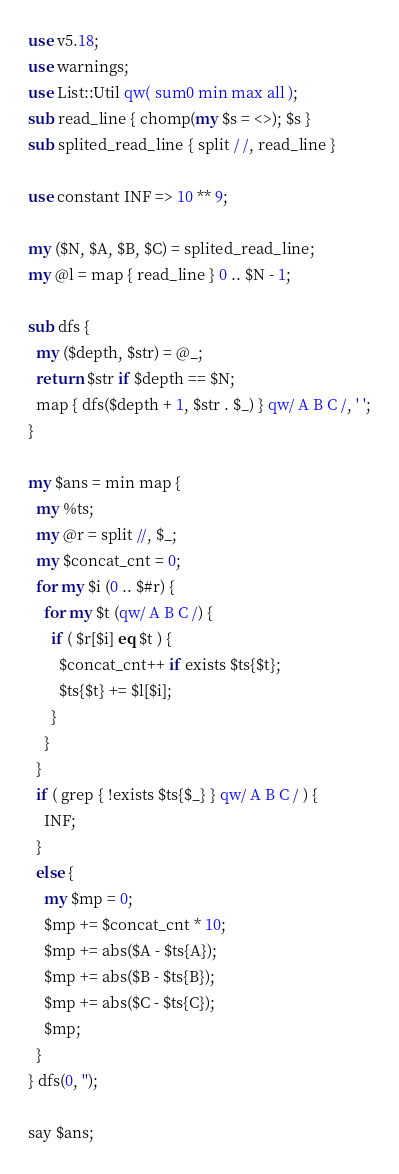Convert code to text. <code><loc_0><loc_0><loc_500><loc_500><_Perl_>use v5.18;
use warnings;
use List::Util qw( sum0 min max all );
sub read_line { chomp(my $s = <>); $s }
sub splited_read_line { split / /, read_line }

use constant INF => 10 ** 9;

my ($N, $A, $B, $C) = splited_read_line;
my @l = map { read_line } 0 .. $N - 1;

sub dfs {
  my ($depth, $str) = @_;
  return $str if $depth == $N;
  map { dfs($depth + 1, $str . $_) } qw/ A B C /, ' ';
}

my $ans = min map {
  my %ts;
  my @r = split //, $_;
  my $concat_cnt = 0;
  for my $i (0 .. $#r) {
    for my $t (qw/ A B C /) {
      if ( $r[$i] eq $t ) {
        $concat_cnt++ if exists $ts{$t};
        $ts{$t} += $l[$i];
      }
    }
  }
  if ( grep { !exists $ts{$_} } qw/ A B C / ) {
    INF;
  }
  else {
    my $mp = 0;
    $mp += $concat_cnt * 10;
    $mp += abs($A - $ts{A});
    $mp += abs($B - $ts{B});
    $mp += abs($C - $ts{C});
    $mp;
  }
} dfs(0, '');

say $ans;</code> 